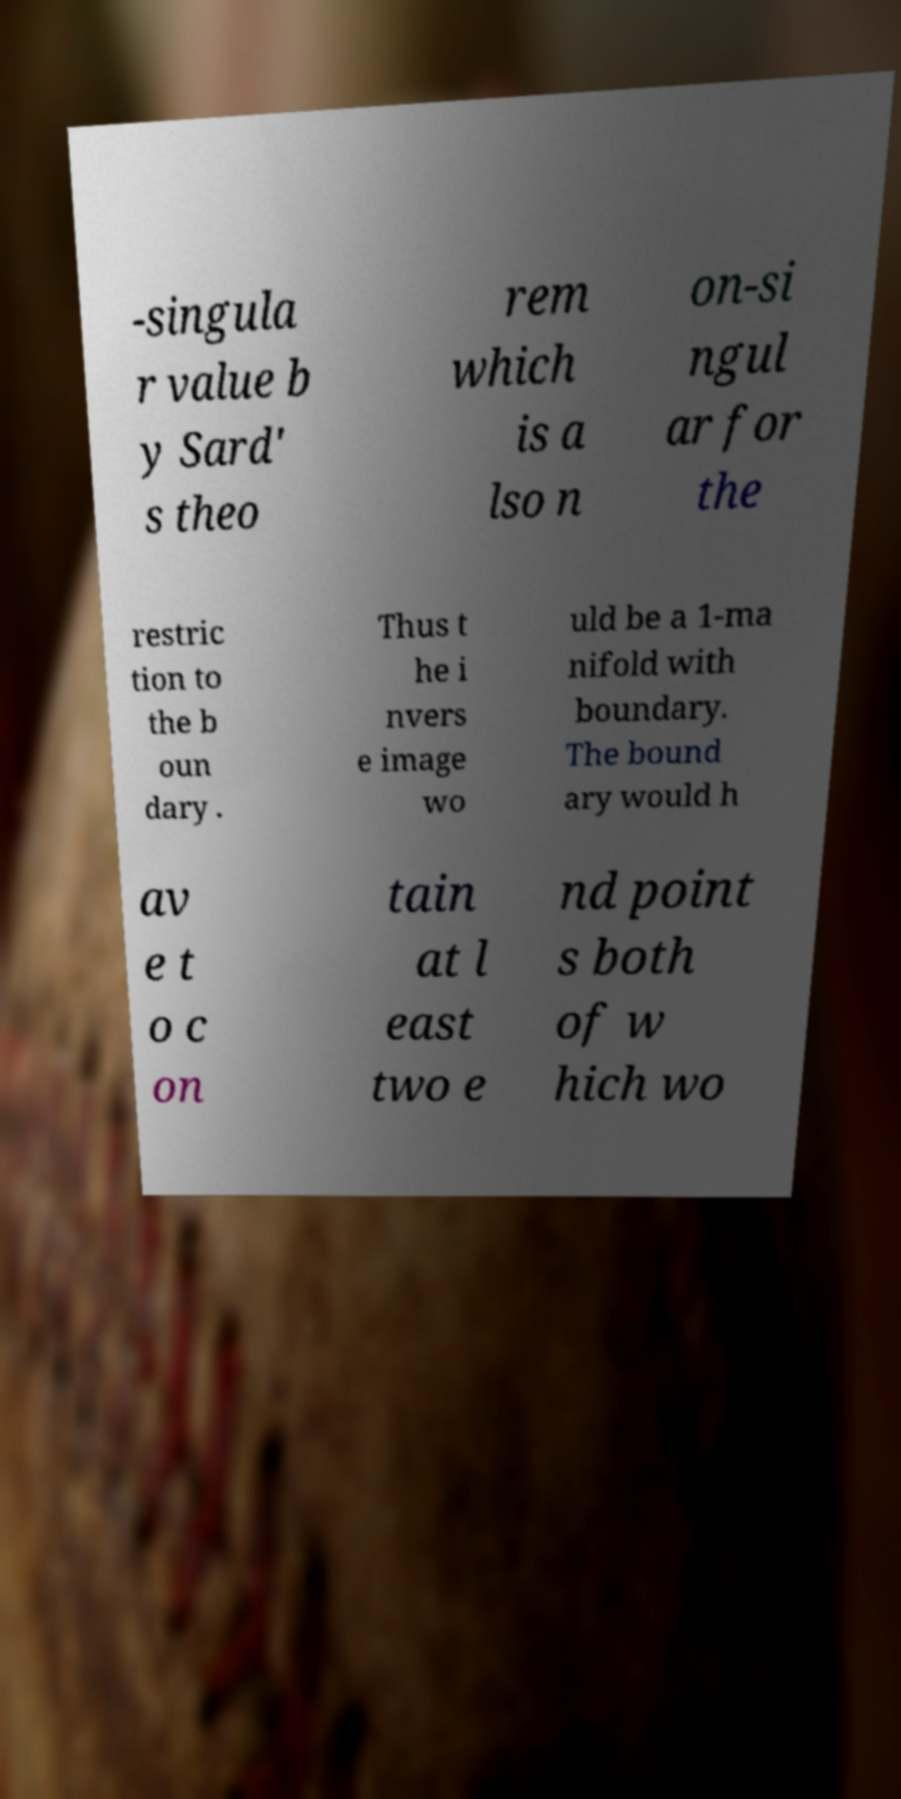I need the written content from this picture converted into text. Can you do that? -singula r value b y Sard' s theo rem which is a lso n on-si ngul ar for the restric tion to the b oun dary . Thus t he i nvers e image wo uld be a 1-ma nifold with boundary. The bound ary would h av e t o c on tain at l east two e nd point s both of w hich wo 